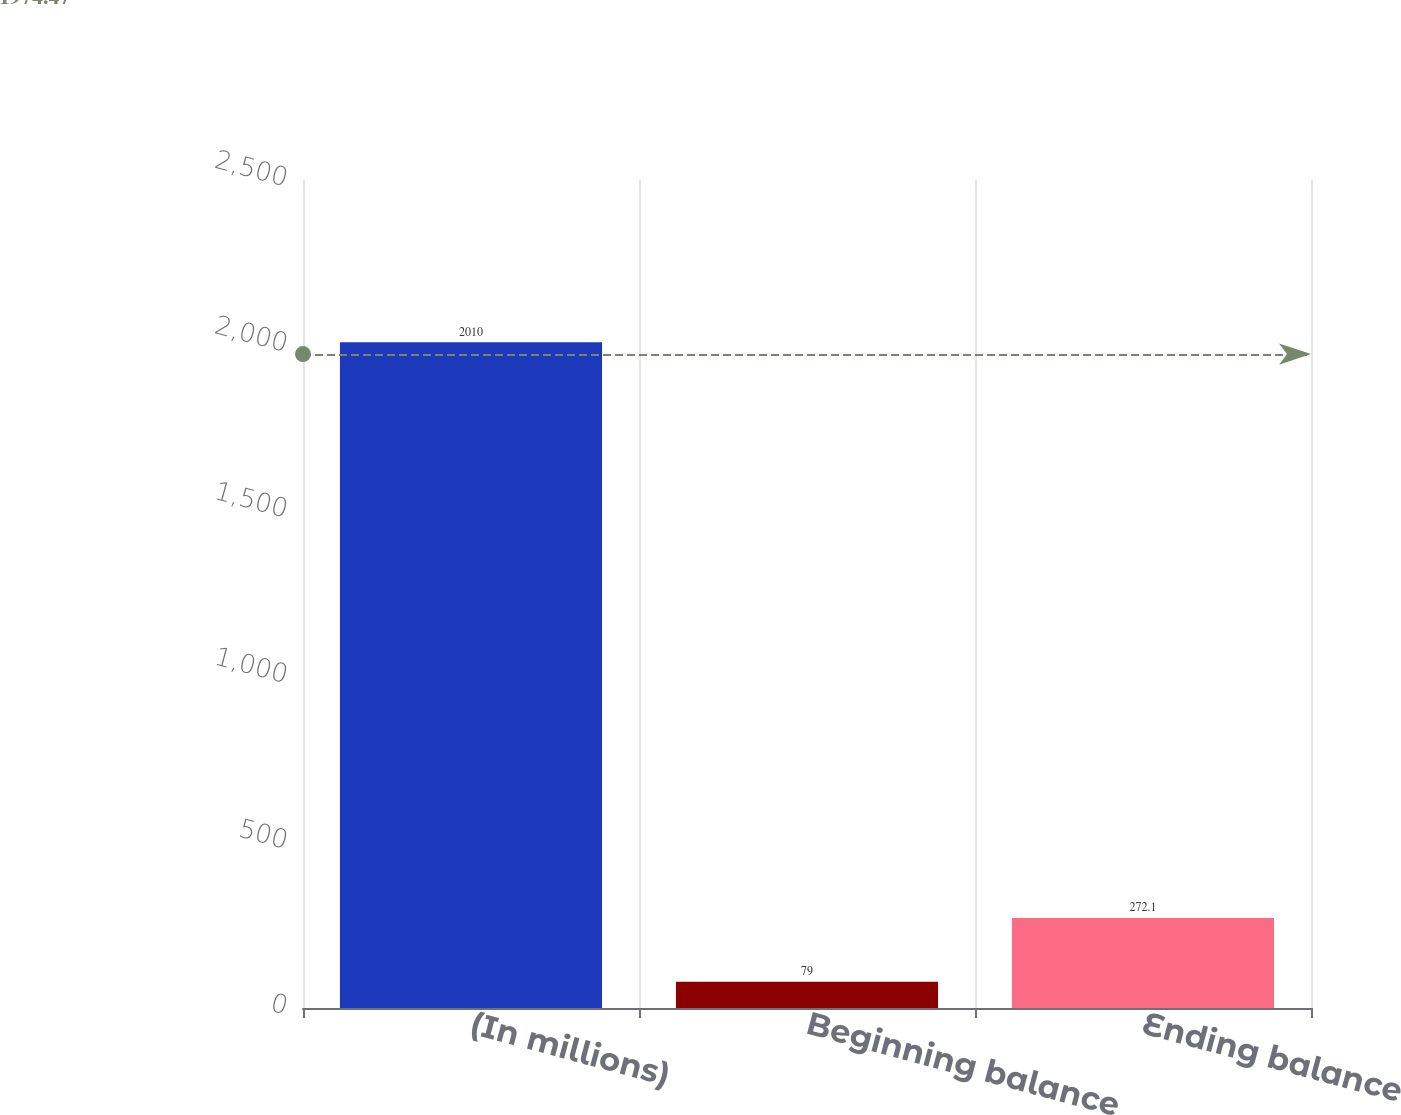Convert chart to OTSL. <chart><loc_0><loc_0><loc_500><loc_500><bar_chart><fcel>(In millions)<fcel>Beginning balance<fcel>Ending balance<nl><fcel>2010<fcel>79<fcel>272.1<nl></chart> 